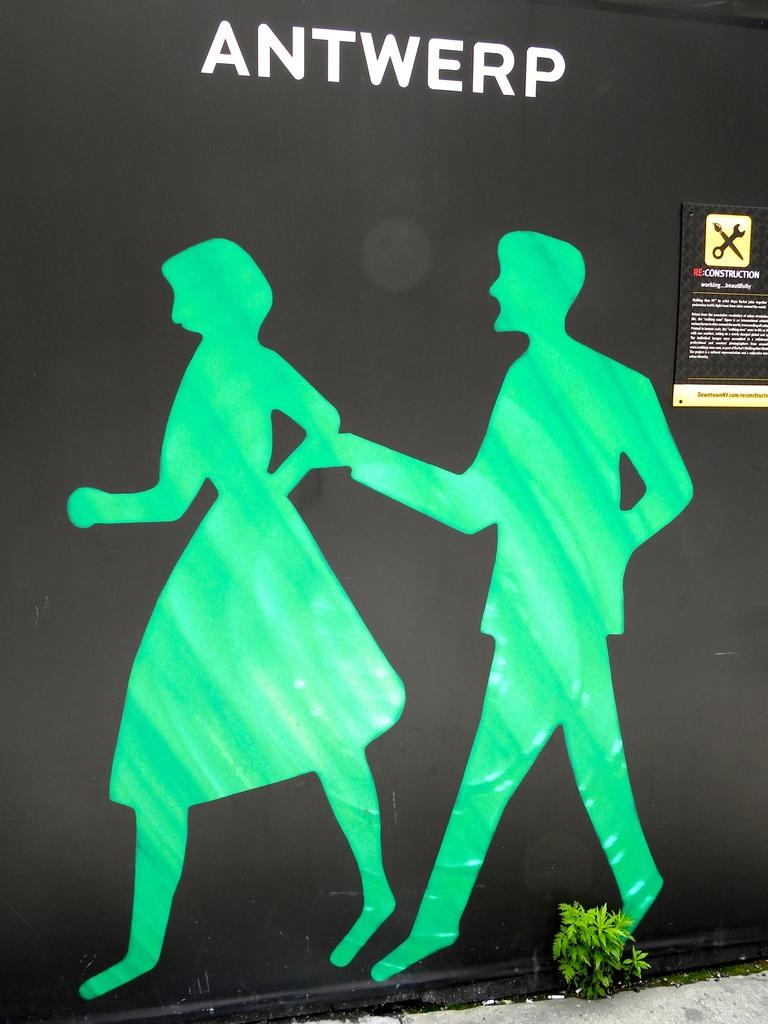<image>
Render a clear and concise summary of the photo. Two silhouettes in green are on a black background with the word ANTWERP over their head 